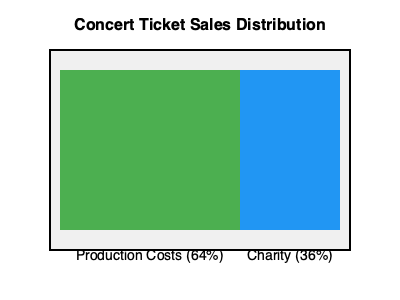Your rock star sibling's latest charity concert generated $500,000 in ticket sales. Based on the chart showing the distribution of funds, how much money will be allocated to the charitable cause? To solve this problem, we'll follow these steps:

1. Identify the percentage allocated to charity from the chart:
   The chart shows that 36% of ticket sales go to charity.

2. Set up the equation to calculate the charity amount:
   Let $x$ be the amount allocated to charity.
   $x = 36\% \text{ of } \$500,000$

3. Convert the percentage to a decimal:
   $36\% = 0.36$

4. Multiply the total sales by the decimal form of the percentage:
   $x = 0.36 \times \$500,000$

5. Perform the calculation:
   $x = \$180,000$

Therefore, $180,000 will be allocated to the charitable cause.
Answer: $180,000 